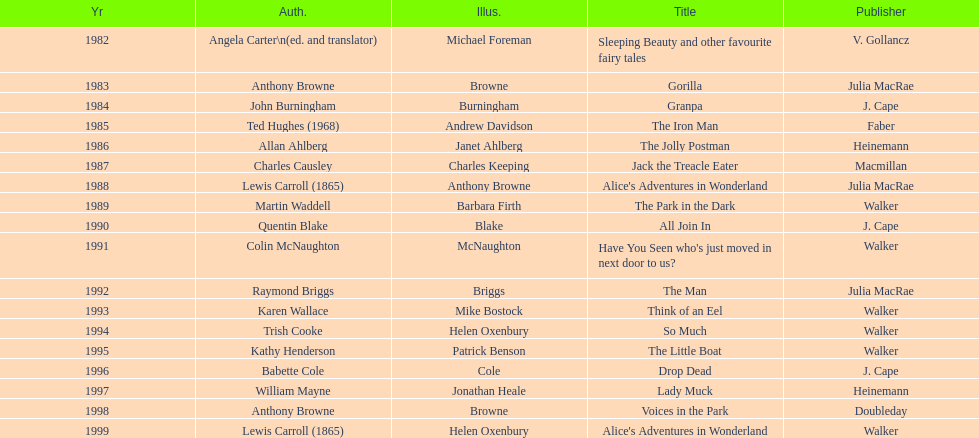Which author wrote the first award winner? Angela Carter. 